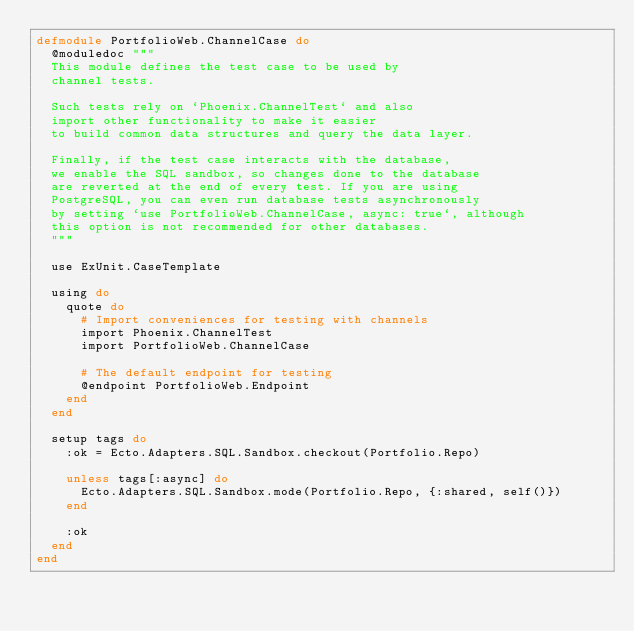Convert code to text. <code><loc_0><loc_0><loc_500><loc_500><_Elixir_>defmodule PortfolioWeb.ChannelCase do
  @moduledoc """
  This module defines the test case to be used by
  channel tests.

  Such tests rely on `Phoenix.ChannelTest` and also
  import other functionality to make it easier
  to build common data structures and query the data layer.

  Finally, if the test case interacts with the database,
  we enable the SQL sandbox, so changes done to the database
  are reverted at the end of every test. If you are using
  PostgreSQL, you can even run database tests asynchronously
  by setting `use PortfolioWeb.ChannelCase, async: true`, although
  this option is not recommended for other databases.
  """

  use ExUnit.CaseTemplate

  using do
    quote do
      # Import conveniences for testing with channels
      import Phoenix.ChannelTest
      import PortfolioWeb.ChannelCase

      # The default endpoint for testing
      @endpoint PortfolioWeb.Endpoint
    end
  end

  setup tags do
    :ok = Ecto.Adapters.SQL.Sandbox.checkout(Portfolio.Repo)

    unless tags[:async] do
      Ecto.Adapters.SQL.Sandbox.mode(Portfolio.Repo, {:shared, self()})
    end

    :ok
  end
end
</code> 